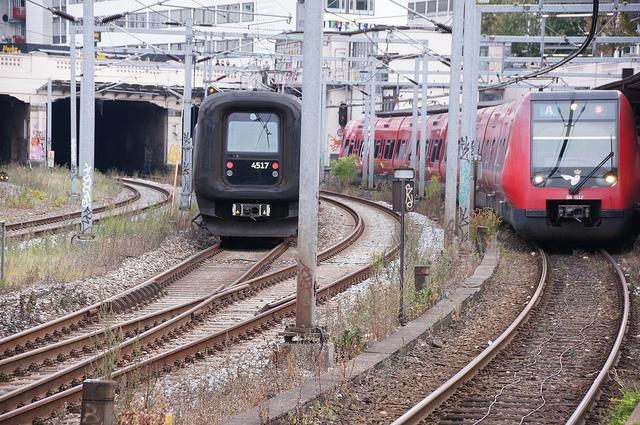The trains have what safety feature on the glass to help see visibly in stormy weather? wipers 